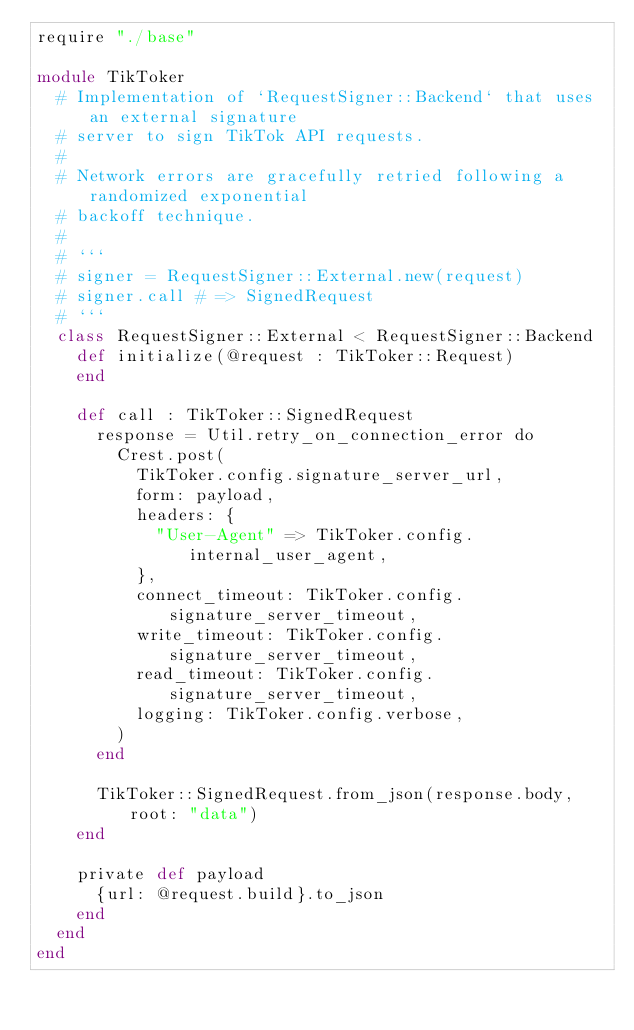<code> <loc_0><loc_0><loc_500><loc_500><_Crystal_>require "./base"

module TikToker
  # Implementation of `RequestSigner::Backend` that uses an external signature
  # server to sign TikTok API requests.
  #
  # Network errors are gracefully retried following a randomized exponential
  # backoff technique.
  #
  # ```
  # signer = RequestSigner::External.new(request)
  # signer.call # => SignedRequest
  # ```
  class RequestSigner::External < RequestSigner::Backend
    def initialize(@request : TikToker::Request)
    end

    def call : TikToker::SignedRequest
      response = Util.retry_on_connection_error do
        Crest.post(
          TikToker.config.signature_server_url,
          form: payload,
          headers: {
            "User-Agent" => TikToker.config.internal_user_agent,
          },
          connect_timeout: TikToker.config.signature_server_timeout,
          write_timeout: TikToker.config.signature_server_timeout,
          read_timeout: TikToker.config.signature_server_timeout,
          logging: TikToker.config.verbose,
        )
      end

      TikToker::SignedRequest.from_json(response.body, root: "data")
    end

    private def payload
      {url: @request.build}.to_json
    end
  end
end
</code> 